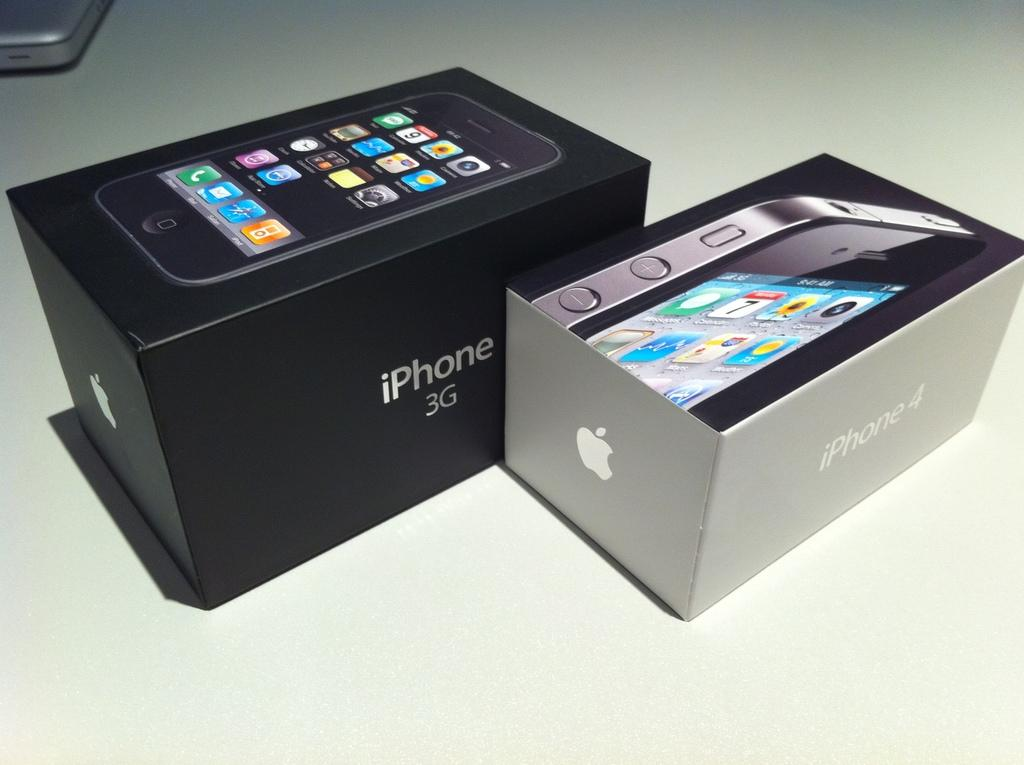Provide a one-sentence caption for the provided image. A black box with the iPhone 3G logo sits next to a silver box with the iPhone 4 logo. 